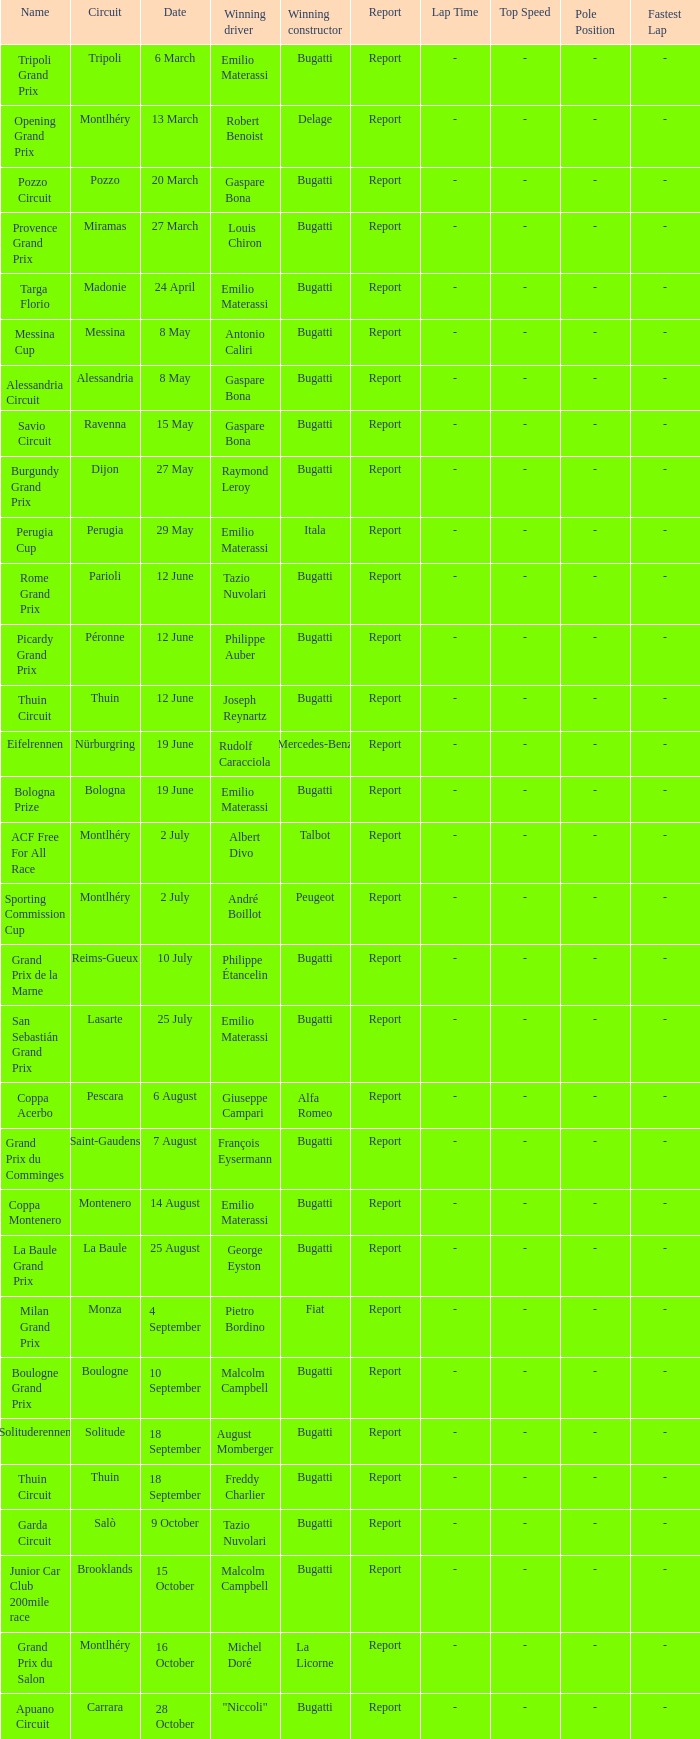When did Gaspare Bona win the Pozzo Circuit? 20 March. 